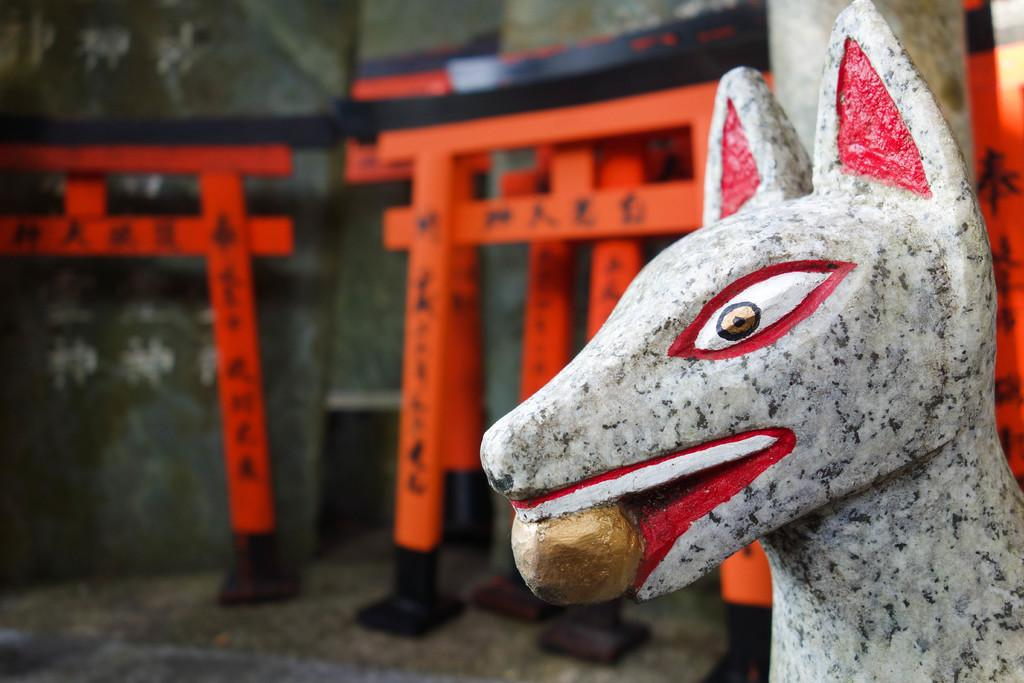What type of statue is on the right side of the image? There is a statue of an animal on the right side of the image. What can be seen in the background of the image? There are poles and a wall visible in the background of the image. What is the color of the poles? The poles are in orange color. Where are the poles located in relation to the floor? The poles are on the floor. What sense can be experienced from the statue in the image? The image is a visual representation, so no other senses can be experienced from the statue in the image. 